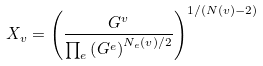Convert formula to latex. <formula><loc_0><loc_0><loc_500><loc_500>X _ { v } = \left ( \frac { G ^ { v } } { \prod _ { e } \left ( G ^ { e } \right ) ^ { N _ { e } ( v ) / 2 } } \right ) ^ { 1 / ( N ( v ) - 2 ) }</formula> 